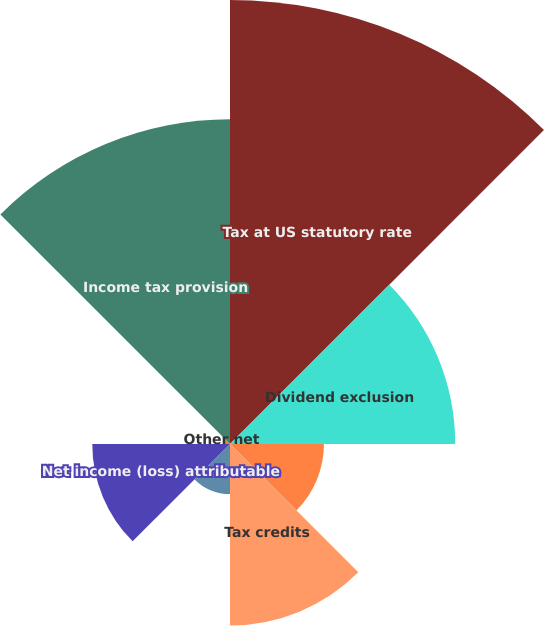<chart> <loc_0><loc_0><loc_500><loc_500><pie_chart><fcel>Tax at US statutory rate<fcel>Dividend exclusion<fcel>Tax-exempt interest income<fcel>Tax credits<fcel>State taxes net of federal<fcel>Net income (loss) attributable<fcel>Other net<fcel>Income tax provision<nl><fcel>30.34%<fcel>15.39%<fcel>6.42%<fcel>12.4%<fcel>3.42%<fcel>9.41%<fcel>0.43%<fcel>22.19%<nl></chart> 